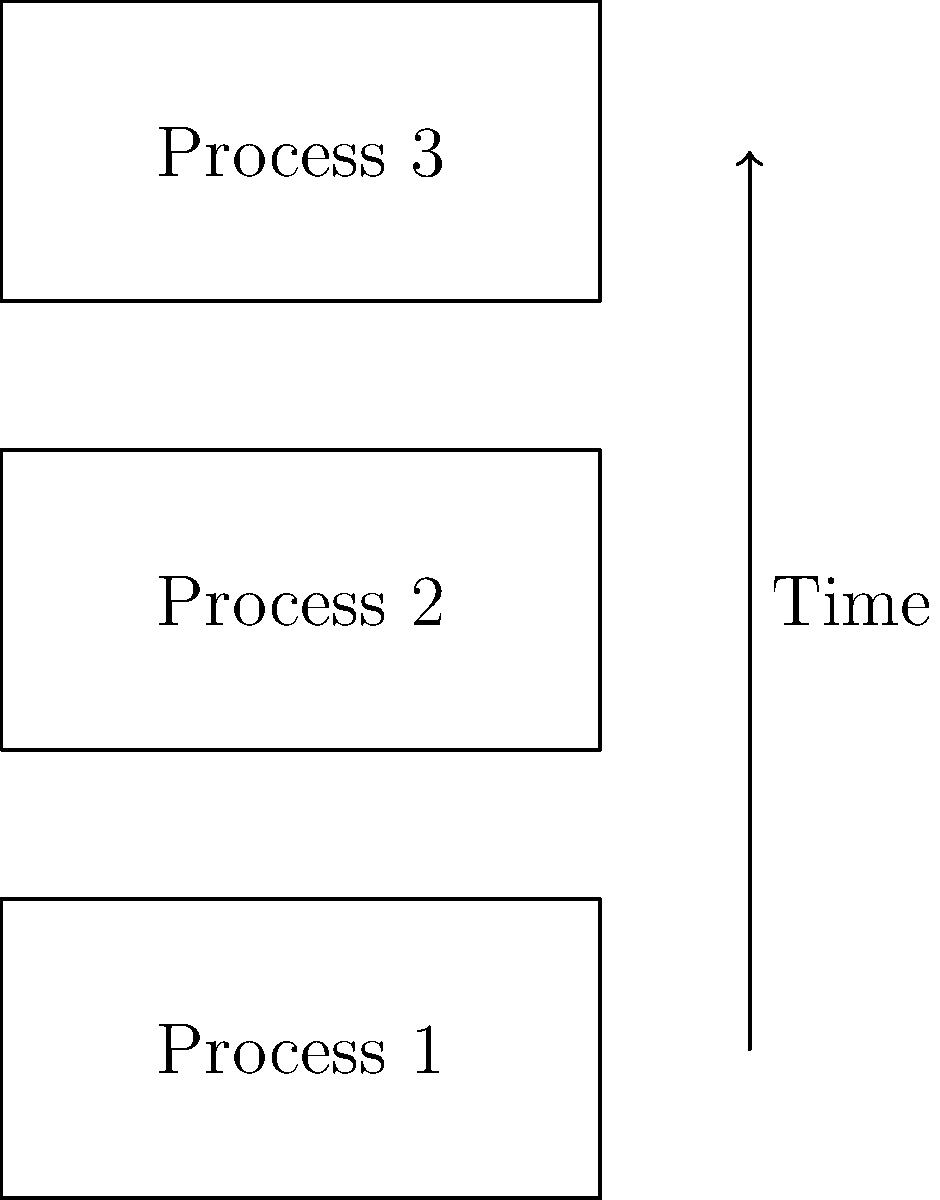In a multithreading diagram, three parallel processes are represented by congruent rectangles. If the width of each rectangle is 40 units and the total area covered by all three rectangles is 1800 square units, what is the height of each rectangle? Let's approach this step-by-step:

1) We know that the rectangles are congruent, meaning they have the same dimensions.

2) Let's denote the height of each rectangle as $h$.

3) The width of each rectangle is given as 40 units.

4) The area of a single rectangle is given by:
   $A = w \times h = 40h$

5) We have three rectangles, so the total area is:
   $A_{total} = 3 \times (40h) = 120h$

6) We're told that the total area is 1800 square units:
   $120h = 1800$

7) Solving for $h$:
   $h = 1800 \div 120 = 15$

Therefore, the height of each rectangle is 15 units.
Answer: 15 units 